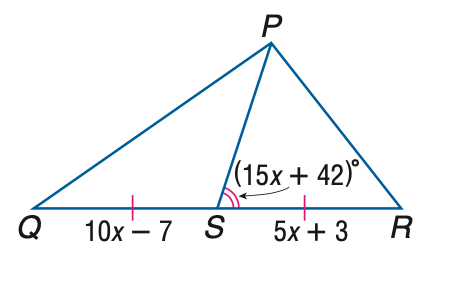Answer the mathemtical geometry problem and directly provide the correct option letter.
Question: Find x if P S is a median of \triangle P Q R.
Choices: A: 1 B: 2 C: 3 D: 4 B 